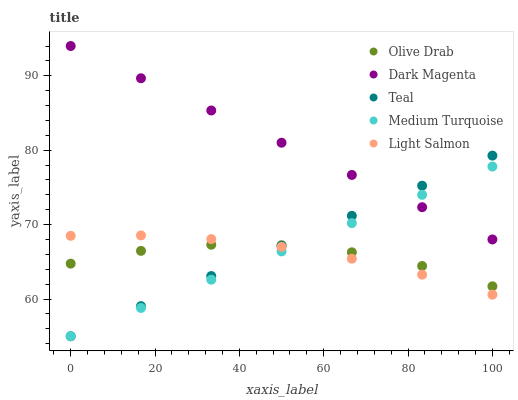Does Olive Drab have the minimum area under the curve?
Answer yes or no. Yes. Does Dark Magenta have the maximum area under the curve?
Answer yes or no. Yes. Does Medium Turquoise have the minimum area under the curve?
Answer yes or no. No. Does Medium Turquoise have the maximum area under the curve?
Answer yes or no. No. Is Medium Turquoise the smoothest?
Answer yes or no. Yes. Is Olive Drab the roughest?
Answer yes or no. Yes. Is Dark Magenta the smoothest?
Answer yes or no. No. Is Dark Magenta the roughest?
Answer yes or no. No. Does Teal have the lowest value?
Answer yes or no. Yes. Does Dark Magenta have the lowest value?
Answer yes or no. No. Does Dark Magenta have the highest value?
Answer yes or no. Yes. Does Medium Turquoise have the highest value?
Answer yes or no. No. Is Olive Drab less than Dark Magenta?
Answer yes or no. Yes. Is Dark Magenta greater than Olive Drab?
Answer yes or no. Yes. Does Light Salmon intersect Teal?
Answer yes or no. Yes. Is Light Salmon less than Teal?
Answer yes or no. No. Is Light Salmon greater than Teal?
Answer yes or no. No. Does Olive Drab intersect Dark Magenta?
Answer yes or no. No. 